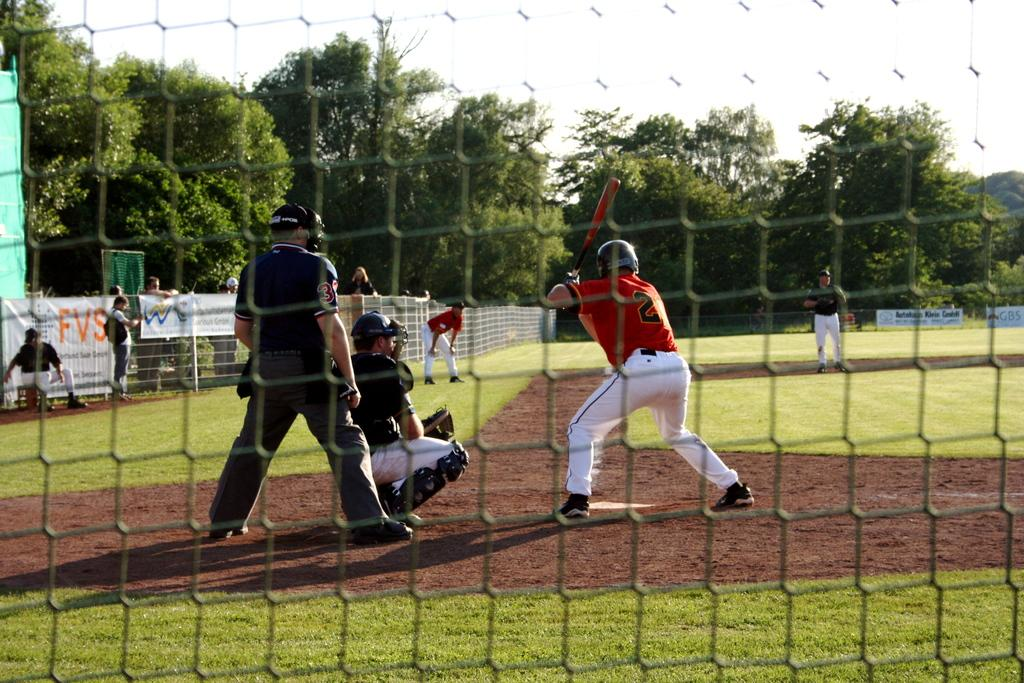<image>
Give a short and clear explanation of the subsequent image. one of the banners on the fence says FVS 